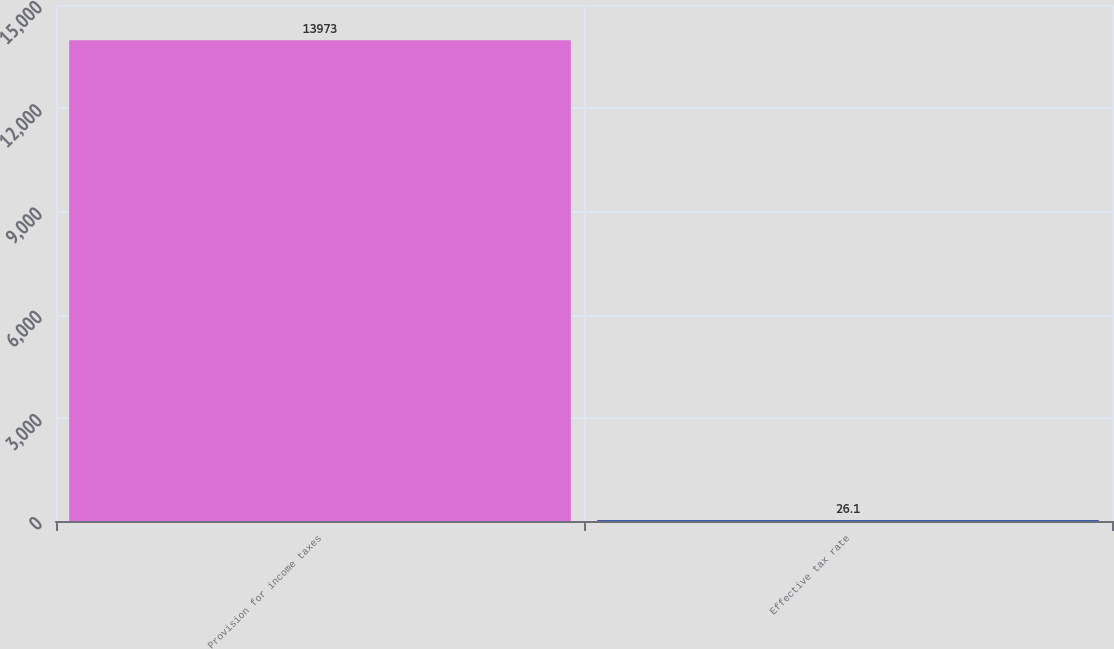<chart> <loc_0><loc_0><loc_500><loc_500><bar_chart><fcel>Provision for income taxes<fcel>Effective tax rate<nl><fcel>13973<fcel>26.1<nl></chart> 